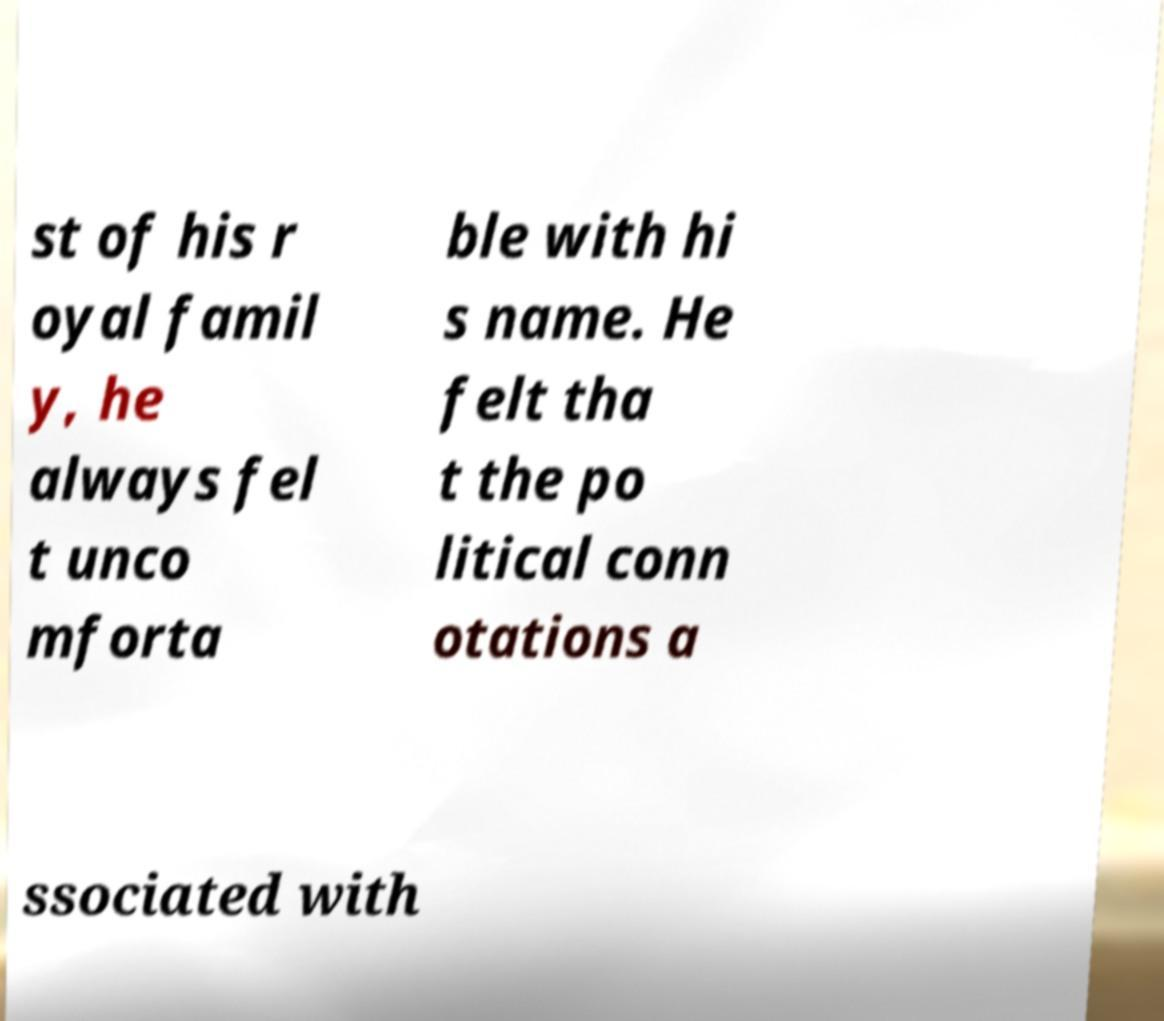What messages or text are displayed in this image? I need them in a readable, typed format. st of his r oyal famil y, he always fel t unco mforta ble with hi s name. He felt tha t the po litical conn otations a ssociated with 